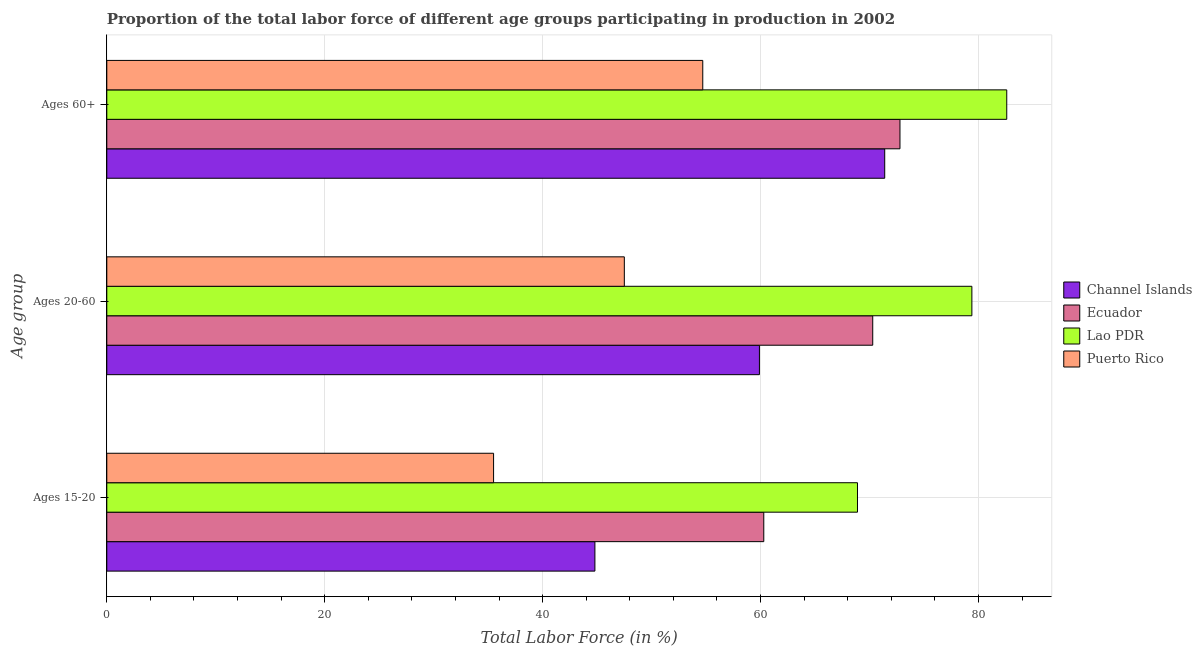How many bars are there on the 3rd tick from the top?
Ensure brevity in your answer.  4. How many bars are there on the 2nd tick from the bottom?
Give a very brief answer. 4. What is the label of the 3rd group of bars from the top?
Keep it short and to the point. Ages 15-20. What is the percentage of labor force within the age group 20-60 in Ecuador?
Ensure brevity in your answer.  70.3. Across all countries, what is the maximum percentage of labor force above age 60?
Your response must be concise. 82.6. Across all countries, what is the minimum percentage of labor force above age 60?
Provide a succinct answer. 54.7. In which country was the percentage of labor force above age 60 maximum?
Your answer should be very brief. Lao PDR. In which country was the percentage of labor force within the age group 20-60 minimum?
Provide a short and direct response. Puerto Rico. What is the total percentage of labor force within the age group 20-60 in the graph?
Ensure brevity in your answer.  257.1. What is the difference between the percentage of labor force within the age group 15-20 in Lao PDR and that in Puerto Rico?
Your answer should be very brief. 33.4. What is the difference between the percentage of labor force above age 60 in Ecuador and the percentage of labor force within the age group 20-60 in Lao PDR?
Ensure brevity in your answer.  -6.6. What is the average percentage of labor force within the age group 15-20 per country?
Offer a very short reply. 52.37. What is the difference between the percentage of labor force above age 60 and percentage of labor force within the age group 15-20 in Ecuador?
Give a very brief answer. 12.5. What is the ratio of the percentage of labor force within the age group 15-20 in Lao PDR to that in Puerto Rico?
Offer a very short reply. 1.94. Is the difference between the percentage of labor force within the age group 20-60 in Ecuador and Channel Islands greater than the difference between the percentage of labor force within the age group 15-20 in Ecuador and Channel Islands?
Your response must be concise. No. What is the difference between the highest and the second highest percentage of labor force above age 60?
Ensure brevity in your answer.  9.8. What is the difference between the highest and the lowest percentage of labor force within the age group 20-60?
Your answer should be compact. 31.9. What does the 2nd bar from the top in Ages 15-20 represents?
Keep it short and to the point. Lao PDR. What does the 1st bar from the bottom in Ages 15-20 represents?
Provide a succinct answer. Channel Islands. How many bars are there?
Ensure brevity in your answer.  12. How many countries are there in the graph?
Provide a short and direct response. 4. Are the values on the major ticks of X-axis written in scientific E-notation?
Keep it short and to the point. No. Does the graph contain any zero values?
Your answer should be very brief. No. How are the legend labels stacked?
Offer a very short reply. Vertical. What is the title of the graph?
Your response must be concise. Proportion of the total labor force of different age groups participating in production in 2002. What is the label or title of the X-axis?
Provide a short and direct response. Total Labor Force (in %). What is the label or title of the Y-axis?
Make the answer very short. Age group. What is the Total Labor Force (in %) of Channel Islands in Ages 15-20?
Offer a very short reply. 44.8. What is the Total Labor Force (in %) of Ecuador in Ages 15-20?
Your answer should be compact. 60.3. What is the Total Labor Force (in %) of Lao PDR in Ages 15-20?
Give a very brief answer. 68.9. What is the Total Labor Force (in %) of Puerto Rico in Ages 15-20?
Your answer should be very brief. 35.5. What is the Total Labor Force (in %) in Channel Islands in Ages 20-60?
Give a very brief answer. 59.9. What is the Total Labor Force (in %) of Ecuador in Ages 20-60?
Keep it short and to the point. 70.3. What is the Total Labor Force (in %) in Lao PDR in Ages 20-60?
Ensure brevity in your answer.  79.4. What is the Total Labor Force (in %) in Puerto Rico in Ages 20-60?
Ensure brevity in your answer.  47.5. What is the Total Labor Force (in %) in Channel Islands in Ages 60+?
Offer a terse response. 71.4. What is the Total Labor Force (in %) in Ecuador in Ages 60+?
Your response must be concise. 72.8. What is the Total Labor Force (in %) of Lao PDR in Ages 60+?
Offer a very short reply. 82.6. What is the Total Labor Force (in %) of Puerto Rico in Ages 60+?
Give a very brief answer. 54.7. Across all Age group, what is the maximum Total Labor Force (in %) of Channel Islands?
Your answer should be compact. 71.4. Across all Age group, what is the maximum Total Labor Force (in %) of Ecuador?
Your response must be concise. 72.8. Across all Age group, what is the maximum Total Labor Force (in %) in Lao PDR?
Your answer should be compact. 82.6. Across all Age group, what is the maximum Total Labor Force (in %) in Puerto Rico?
Your answer should be very brief. 54.7. Across all Age group, what is the minimum Total Labor Force (in %) of Channel Islands?
Provide a succinct answer. 44.8. Across all Age group, what is the minimum Total Labor Force (in %) in Ecuador?
Give a very brief answer. 60.3. Across all Age group, what is the minimum Total Labor Force (in %) in Lao PDR?
Your response must be concise. 68.9. Across all Age group, what is the minimum Total Labor Force (in %) in Puerto Rico?
Keep it short and to the point. 35.5. What is the total Total Labor Force (in %) of Channel Islands in the graph?
Keep it short and to the point. 176.1. What is the total Total Labor Force (in %) of Ecuador in the graph?
Your answer should be very brief. 203.4. What is the total Total Labor Force (in %) of Lao PDR in the graph?
Ensure brevity in your answer.  230.9. What is the total Total Labor Force (in %) of Puerto Rico in the graph?
Make the answer very short. 137.7. What is the difference between the Total Labor Force (in %) of Channel Islands in Ages 15-20 and that in Ages 20-60?
Offer a very short reply. -15.1. What is the difference between the Total Labor Force (in %) of Ecuador in Ages 15-20 and that in Ages 20-60?
Provide a succinct answer. -10. What is the difference between the Total Labor Force (in %) in Channel Islands in Ages 15-20 and that in Ages 60+?
Your answer should be compact. -26.6. What is the difference between the Total Labor Force (in %) of Ecuador in Ages 15-20 and that in Ages 60+?
Offer a very short reply. -12.5. What is the difference between the Total Labor Force (in %) of Lao PDR in Ages 15-20 and that in Ages 60+?
Your answer should be very brief. -13.7. What is the difference between the Total Labor Force (in %) of Puerto Rico in Ages 15-20 and that in Ages 60+?
Provide a short and direct response. -19.2. What is the difference between the Total Labor Force (in %) of Ecuador in Ages 20-60 and that in Ages 60+?
Your answer should be compact. -2.5. What is the difference between the Total Labor Force (in %) of Puerto Rico in Ages 20-60 and that in Ages 60+?
Ensure brevity in your answer.  -7.2. What is the difference between the Total Labor Force (in %) in Channel Islands in Ages 15-20 and the Total Labor Force (in %) in Ecuador in Ages 20-60?
Your answer should be compact. -25.5. What is the difference between the Total Labor Force (in %) of Channel Islands in Ages 15-20 and the Total Labor Force (in %) of Lao PDR in Ages 20-60?
Give a very brief answer. -34.6. What is the difference between the Total Labor Force (in %) in Ecuador in Ages 15-20 and the Total Labor Force (in %) in Lao PDR in Ages 20-60?
Give a very brief answer. -19.1. What is the difference between the Total Labor Force (in %) in Lao PDR in Ages 15-20 and the Total Labor Force (in %) in Puerto Rico in Ages 20-60?
Keep it short and to the point. 21.4. What is the difference between the Total Labor Force (in %) of Channel Islands in Ages 15-20 and the Total Labor Force (in %) of Ecuador in Ages 60+?
Provide a succinct answer. -28. What is the difference between the Total Labor Force (in %) of Channel Islands in Ages 15-20 and the Total Labor Force (in %) of Lao PDR in Ages 60+?
Ensure brevity in your answer.  -37.8. What is the difference between the Total Labor Force (in %) of Ecuador in Ages 15-20 and the Total Labor Force (in %) of Lao PDR in Ages 60+?
Offer a very short reply. -22.3. What is the difference between the Total Labor Force (in %) of Lao PDR in Ages 15-20 and the Total Labor Force (in %) of Puerto Rico in Ages 60+?
Provide a succinct answer. 14.2. What is the difference between the Total Labor Force (in %) in Channel Islands in Ages 20-60 and the Total Labor Force (in %) in Lao PDR in Ages 60+?
Give a very brief answer. -22.7. What is the difference between the Total Labor Force (in %) of Ecuador in Ages 20-60 and the Total Labor Force (in %) of Lao PDR in Ages 60+?
Your response must be concise. -12.3. What is the difference between the Total Labor Force (in %) of Ecuador in Ages 20-60 and the Total Labor Force (in %) of Puerto Rico in Ages 60+?
Give a very brief answer. 15.6. What is the difference between the Total Labor Force (in %) of Lao PDR in Ages 20-60 and the Total Labor Force (in %) of Puerto Rico in Ages 60+?
Keep it short and to the point. 24.7. What is the average Total Labor Force (in %) of Channel Islands per Age group?
Provide a succinct answer. 58.7. What is the average Total Labor Force (in %) in Ecuador per Age group?
Your answer should be very brief. 67.8. What is the average Total Labor Force (in %) in Lao PDR per Age group?
Offer a terse response. 76.97. What is the average Total Labor Force (in %) of Puerto Rico per Age group?
Your response must be concise. 45.9. What is the difference between the Total Labor Force (in %) in Channel Islands and Total Labor Force (in %) in Ecuador in Ages 15-20?
Provide a succinct answer. -15.5. What is the difference between the Total Labor Force (in %) in Channel Islands and Total Labor Force (in %) in Lao PDR in Ages 15-20?
Offer a terse response. -24.1. What is the difference between the Total Labor Force (in %) of Channel Islands and Total Labor Force (in %) of Puerto Rico in Ages 15-20?
Make the answer very short. 9.3. What is the difference between the Total Labor Force (in %) of Ecuador and Total Labor Force (in %) of Puerto Rico in Ages 15-20?
Ensure brevity in your answer.  24.8. What is the difference between the Total Labor Force (in %) of Lao PDR and Total Labor Force (in %) of Puerto Rico in Ages 15-20?
Provide a short and direct response. 33.4. What is the difference between the Total Labor Force (in %) of Channel Islands and Total Labor Force (in %) of Ecuador in Ages 20-60?
Ensure brevity in your answer.  -10.4. What is the difference between the Total Labor Force (in %) of Channel Islands and Total Labor Force (in %) of Lao PDR in Ages 20-60?
Give a very brief answer. -19.5. What is the difference between the Total Labor Force (in %) in Channel Islands and Total Labor Force (in %) in Puerto Rico in Ages 20-60?
Make the answer very short. 12.4. What is the difference between the Total Labor Force (in %) in Ecuador and Total Labor Force (in %) in Lao PDR in Ages 20-60?
Your response must be concise. -9.1. What is the difference between the Total Labor Force (in %) in Ecuador and Total Labor Force (in %) in Puerto Rico in Ages 20-60?
Provide a succinct answer. 22.8. What is the difference between the Total Labor Force (in %) in Lao PDR and Total Labor Force (in %) in Puerto Rico in Ages 20-60?
Offer a terse response. 31.9. What is the difference between the Total Labor Force (in %) in Channel Islands and Total Labor Force (in %) in Lao PDR in Ages 60+?
Offer a very short reply. -11.2. What is the difference between the Total Labor Force (in %) in Channel Islands and Total Labor Force (in %) in Puerto Rico in Ages 60+?
Offer a terse response. 16.7. What is the difference between the Total Labor Force (in %) of Ecuador and Total Labor Force (in %) of Lao PDR in Ages 60+?
Provide a succinct answer. -9.8. What is the difference between the Total Labor Force (in %) of Lao PDR and Total Labor Force (in %) of Puerto Rico in Ages 60+?
Make the answer very short. 27.9. What is the ratio of the Total Labor Force (in %) in Channel Islands in Ages 15-20 to that in Ages 20-60?
Your answer should be very brief. 0.75. What is the ratio of the Total Labor Force (in %) of Ecuador in Ages 15-20 to that in Ages 20-60?
Your response must be concise. 0.86. What is the ratio of the Total Labor Force (in %) of Lao PDR in Ages 15-20 to that in Ages 20-60?
Offer a very short reply. 0.87. What is the ratio of the Total Labor Force (in %) in Puerto Rico in Ages 15-20 to that in Ages 20-60?
Your answer should be compact. 0.75. What is the ratio of the Total Labor Force (in %) of Channel Islands in Ages 15-20 to that in Ages 60+?
Give a very brief answer. 0.63. What is the ratio of the Total Labor Force (in %) in Ecuador in Ages 15-20 to that in Ages 60+?
Your answer should be very brief. 0.83. What is the ratio of the Total Labor Force (in %) of Lao PDR in Ages 15-20 to that in Ages 60+?
Your answer should be compact. 0.83. What is the ratio of the Total Labor Force (in %) of Puerto Rico in Ages 15-20 to that in Ages 60+?
Offer a terse response. 0.65. What is the ratio of the Total Labor Force (in %) of Channel Islands in Ages 20-60 to that in Ages 60+?
Your answer should be compact. 0.84. What is the ratio of the Total Labor Force (in %) of Ecuador in Ages 20-60 to that in Ages 60+?
Keep it short and to the point. 0.97. What is the ratio of the Total Labor Force (in %) of Lao PDR in Ages 20-60 to that in Ages 60+?
Your answer should be very brief. 0.96. What is the ratio of the Total Labor Force (in %) of Puerto Rico in Ages 20-60 to that in Ages 60+?
Your response must be concise. 0.87. What is the difference between the highest and the second highest Total Labor Force (in %) of Ecuador?
Make the answer very short. 2.5. What is the difference between the highest and the lowest Total Labor Force (in %) of Channel Islands?
Your answer should be compact. 26.6. 